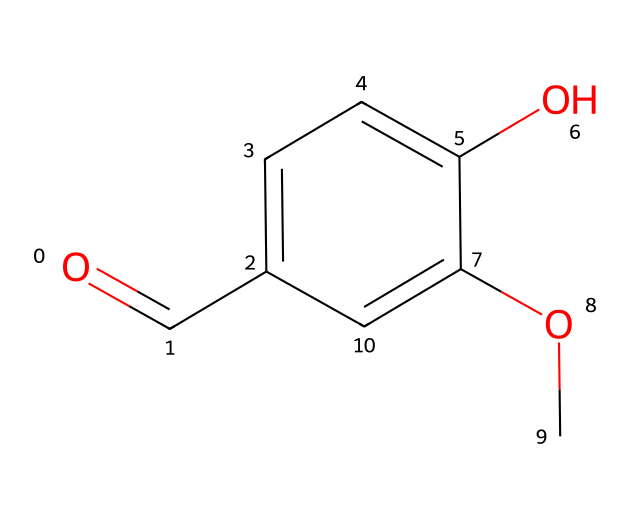What is the total number of carbon atoms in the molecule? Examining the SMILES representation, we count the carbon (C) atoms represented by each ‘c’ and the two occurrences of ‘C’ at the carbonyl (O=C) location. Counting all instances, we see there are eight carbon atoms total.
Answer: eight What functional group is present in this compound? The presence of the carbonyl group (C=O) indicates that this compound contains a ketone functional group, which is characteristic of ketones. This is evident from the structure as well.
Answer: ketone How many hydroxyl (OH) groups does this compound have? Observing the structure, we note the presence of one hydroxyl group attached to one of the aromatic carbons, indicating that vanillin contains a single OH group.
Answer: one What type of aromatic compound does this molecule feature? The compound exhibits an aromatic ring, which consists of six carbon atoms connected by alternating double bonds. This structure is indicative of a phenolic compound due to the hydroxyl substitution.
Answer: phenolic What is the molecular weight of this compound? By calculating the molecular weight of all atoms in the molecule (C8H8O3), we sum the contributions of each atom type: (12.01 g/mol for C, 1.008 g/mol for H, and 16.00 g/mol for O), yielding a total molecular weight of approximately 152.15 g/mol.
Answer: 152.15 Does this molecule exhibit any chiral centers? A chiral center is typically identified by a carbon atom connected to four different substituents. In the provided structure, we find no such carbon atom fulfilling that requirement, indicating that vanillin does not have chiral centers.
Answer: no What is the common use of vanillin in traditional Kōchi desserts? Vanillin, derived from vanilla beans and also synthesized chemically, is primarily used as a flavoring agent, known for imparting a sweet, aromatic flavor characteristic of vanilla in various desserts such as traditional sweets in Kōchi.
Answer: flavoring agent 